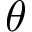<formula> <loc_0><loc_0><loc_500><loc_500>\theta</formula> 